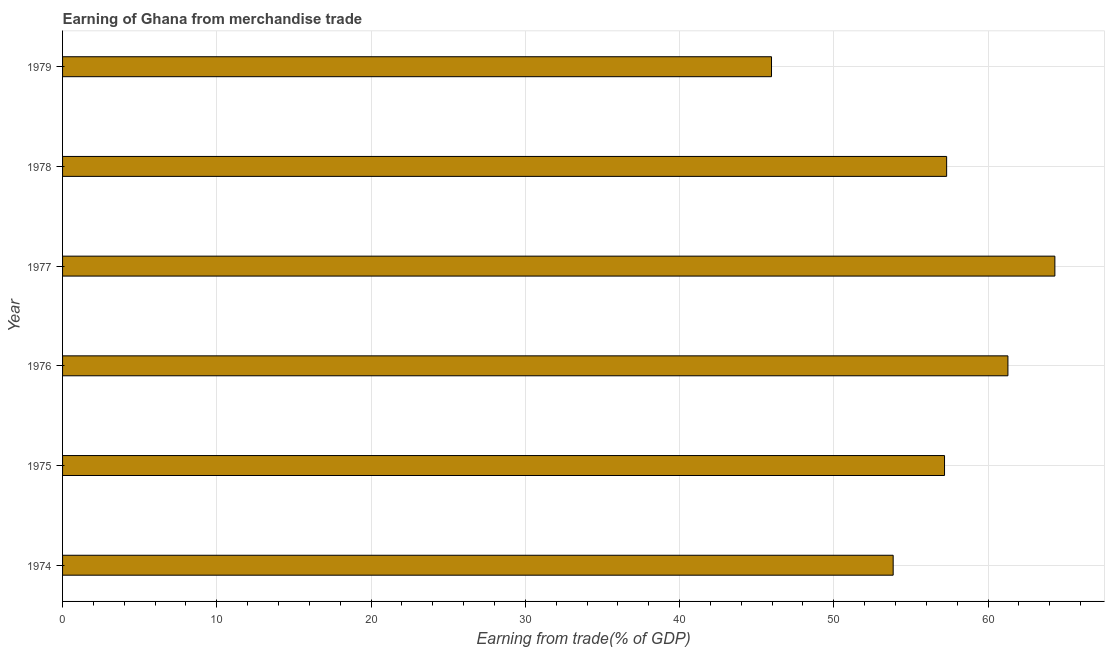Does the graph contain any zero values?
Provide a short and direct response. No. What is the title of the graph?
Provide a short and direct response. Earning of Ghana from merchandise trade. What is the label or title of the X-axis?
Provide a short and direct response. Earning from trade(% of GDP). What is the label or title of the Y-axis?
Keep it short and to the point. Year. What is the earning from merchandise trade in 1974?
Give a very brief answer. 53.85. Across all years, what is the maximum earning from merchandise trade?
Make the answer very short. 64.33. Across all years, what is the minimum earning from merchandise trade?
Give a very brief answer. 45.96. In which year was the earning from merchandise trade maximum?
Offer a terse response. 1977. In which year was the earning from merchandise trade minimum?
Offer a very short reply. 1979. What is the sum of the earning from merchandise trade?
Give a very brief answer. 339.91. What is the difference between the earning from merchandise trade in 1976 and 1977?
Give a very brief answer. -3.04. What is the average earning from merchandise trade per year?
Make the answer very short. 56.65. What is the median earning from merchandise trade?
Ensure brevity in your answer.  57.24. In how many years, is the earning from merchandise trade greater than 46 %?
Make the answer very short. 5. What is the ratio of the earning from merchandise trade in 1974 to that in 1978?
Keep it short and to the point. 0.94. Is the difference between the earning from merchandise trade in 1975 and 1978 greater than the difference between any two years?
Provide a succinct answer. No. What is the difference between the highest and the second highest earning from merchandise trade?
Make the answer very short. 3.04. Is the sum of the earning from merchandise trade in 1974 and 1979 greater than the maximum earning from merchandise trade across all years?
Your answer should be compact. Yes. What is the difference between the highest and the lowest earning from merchandise trade?
Your response must be concise. 18.37. In how many years, is the earning from merchandise trade greater than the average earning from merchandise trade taken over all years?
Ensure brevity in your answer.  4. How many bars are there?
Offer a terse response. 6. Are all the bars in the graph horizontal?
Offer a terse response. Yes. What is the difference between two consecutive major ticks on the X-axis?
Give a very brief answer. 10. Are the values on the major ticks of X-axis written in scientific E-notation?
Give a very brief answer. No. What is the Earning from trade(% of GDP) of 1974?
Make the answer very short. 53.85. What is the Earning from trade(% of GDP) of 1975?
Give a very brief answer. 57.18. What is the Earning from trade(% of GDP) of 1976?
Provide a succinct answer. 61.29. What is the Earning from trade(% of GDP) in 1977?
Ensure brevity in your answer.  64.33. What is the Earning from trade(% of GDP) in 1978?
Your response must be concise. 57.31. What is the Earning from trade(% of GDP) in 1979?
Offer a terse response. 45.96. What is the difference between the Earning from trade(% of GDP) in 1974 and 1975?
Your answer should be very brief. -3.33. What is the difference between the Earning from trade(% of GDP) in 1974 and 1976?
Offer a terse response. -7.44. What is the difference between the Earning from trade(% of GDP) in 1974 and 1977?
Give a very brief answer. -10.48. What is the difference between the Earning from trade(% of GDP) in 1974 and 1978?
Make the answer very short. -3.47. What is the difference between the Earning from trade(% of GDP) in 1974 and 1979?
Provide a short and direct response. 7.89. What is the difference between the Earning from trade(% of GDP) in 1975 and 1976?
Provide a succinct answer. -4.11. What is the difference between the Earning from trade(% of GDP) in 1975 and 1977?
Your response must be concise. -7.15. What is the difference between the Earning from trade(% of GDP) in 1975 and 1978?
Provide a succinct answer. -0.14. What is the difference between the Earning from trade(% of GDP) in 1975 and 1979?
Ensure brevity in your answer.  11.22. What is the difference between the Earning from trade(% of GDP) in 1976 and 1977?
Offer a terse response. -3.04. What is the difference between the Earning from trade(% of GDP) in 1976 and 1978?
Your response must be concise. 3.97. What is the difference between the Earning from trade(% of GDP) in 1976 and 1979?
Offer a very short reply. 15.33. What is the difference between the Earning from trade(% of GDP) in 1977 and 1978?
Make the answer very short. 7.02. What is the difference between the Earning from trade(% of GDP) in 1977 and 1979?
Your answer should be very brief. 18.37. What is the difference between the Earning from trade(% of GDP) in 1978 and 1979?
Offer a very short reply. 11.35. What is the ratio of the Earning from trade(% of GDP) in 1974 to that in 1975?
Provide a short and direct response. 0.94. What is the ratio of the Earning from trade(% of GDP) in 1974 to that in 1976?
Provide a short and direct response. 0.88. What is the ratio of the Earning from trade(% of GDP) in 1974 to that in 1977?
Your response must be concise. 0.84. What is the ratio of the Earning from trade(% of GDP) in 1974 to that in 1979?
Offer a very short reply. 1.17. What is the ratio of the Earning from trade(% of GDP) in 1975 to that in 1976?
Give a very brief answer. 0.93. What is the ratio of the Earning from trade(% of GDP) in 1975 to that in 1977?
Provide a succinct answer. 0.89. What is the ratio of the Earning from trade(% of GDP) in 1975 to that in 1978?
Keep it short and to the point. 1. What is the ratio of the Earning from trade(% of GDP) in 1975 to that in 1979?
Give a very brief answer. 1.24. What is the ratio of the Earning from trade(% of GDP) in 1976 to that in 1977?
Keep it short and to the point. 0.95. What is the ratio of the Earning from trade(% of GDP) in 1976 to that in 1978?
Your answer should be very brief. 1.07. What is the ratio of the Earning from trade(% of GDP) in 1976 to that in 1979?
Offer a terse response. 1.33. What is the ratio of the Earning from trade(% of GDP) in 1977 to that in 1978?
Offer a terse response. 1.12. What is the ratio of the Earning from trade(% of GDP) in 1977 to that in 1979?
Your response must be concise. 1.4. What is the ratio of the Earning from trade(% of GDP) in 1978 to that in 1979?
Give a very brief answer. 1.25. 